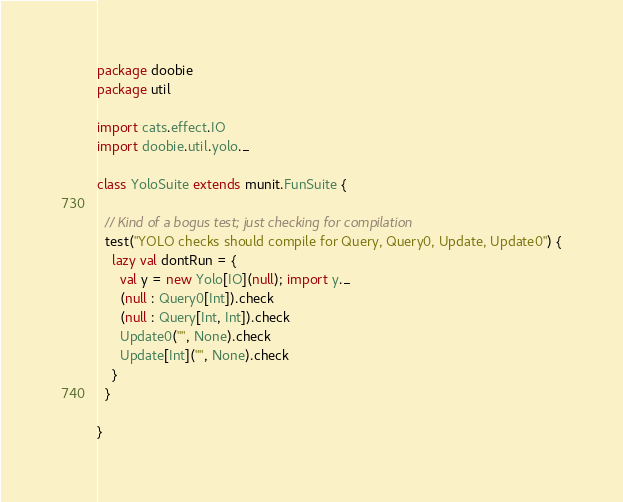Convert code to text. <code><loc_0><loc_0><loc_500><loc_500><_Scala_>package doobie
package util

import cats.effect.IO
import doobie.util.yolo._

class YoloSuite extends munit.FunSuite {

  // Kind of a bogus test; just checking for compilation
  test("YOLO checks should compile for Query, Query0, Update, Update0") {
    lazy val dontRun = {
      val y = new Yolo[IO](null); import y._
      (null : Query0[Int]).check
      (null : Query[Int, Int]).check
      Update0("", None).check
      Update[Int]("", None).check
    }
  }

}
</code> 